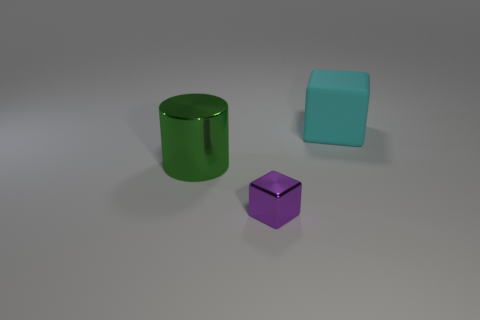Can you tell me the colors of all the objects shown? Certainly! In the image, there are three objects featuring distinct colors. The cylinder is green, the block is aqua or light blue, and the smaller object, which appears to be a cube, is purple. 